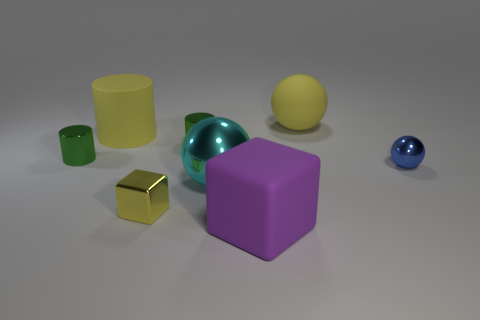What number of spheres are either rubber objects or big things?
Offer a very short reply. 2. There is another object that is the same shape as the big purple object; what is its material?
Give a very brief answer. Metal. There is a cyan sphere that is made of the same material as the blue sphere; what size is it?
Provide a short and direct response. Large. Do the large matte thing that is on the left side of the tiny cube and the small metal object in front of the blue metal thing have the same shape?
Provide a short and direct response. No. What is the color of the block that is the same material as the cyan thing?
Your answer should be very brief. Yellow. There is a shiny sphere that is in front of the blue shiny sphere; does it have the same size as the ball behind the blue object?
Ensure brevity in your answer.  Yes. There is a large thing that is behind the yellow shiny thing and in front of the big cylinder; what is its shape?
Your response must be concise. Sphere. Are there any green objects made of the same material as the blue object?
Make the answer very short. Yes. There is a tiny cube that is the same color as the big rubber sphere; what is it made of?
Offer a very short reply. Metal. Do the large sphere in front of the small blue metal ball and the yellow object that is in front of the small blue thing have the same material?
Provide a short and direct response. Yes. 